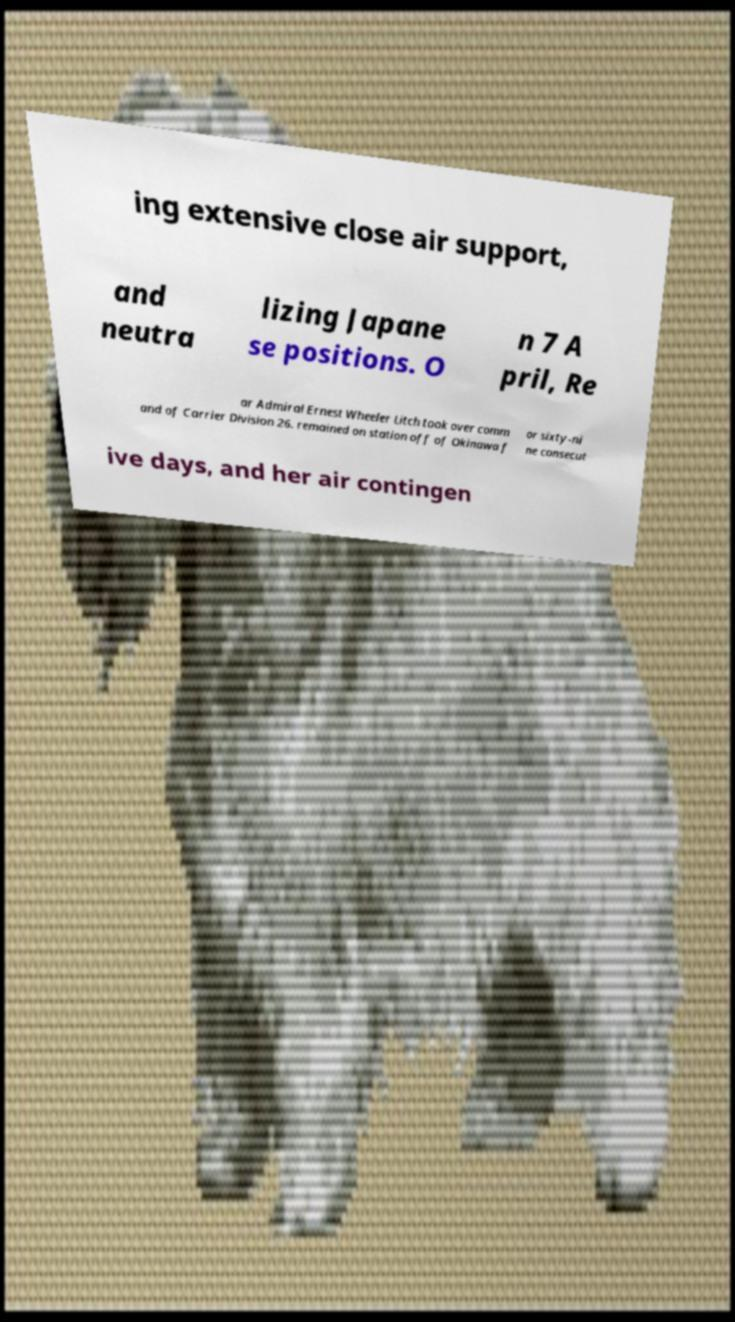Please read and relay the text visible in this image. What does it say? ing extensive close air support, and neutra lizing Japane se positions. O n 7 A pril, Re ar Admiral Ernest Wheeler Litch took over comm and of Carrier Division 26. remained on station off of Okinawa f or sixty-ni ne consecut ive days, and her air contingen 